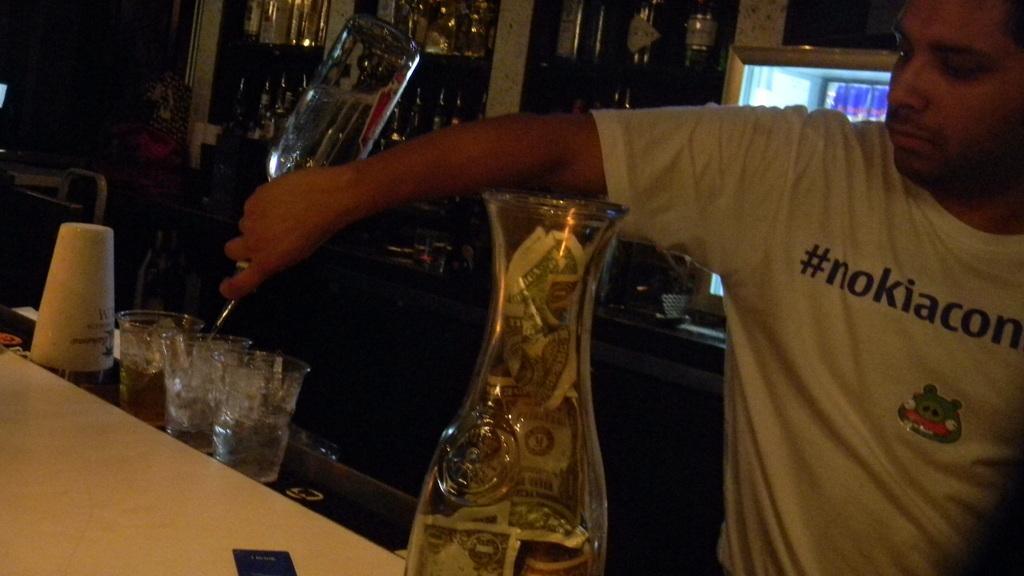In one or two sentences, can you explain what this image depicts? in this image the person is there the table has some glasses,plastic bottles behind the person some bottles are there and background is dark. 